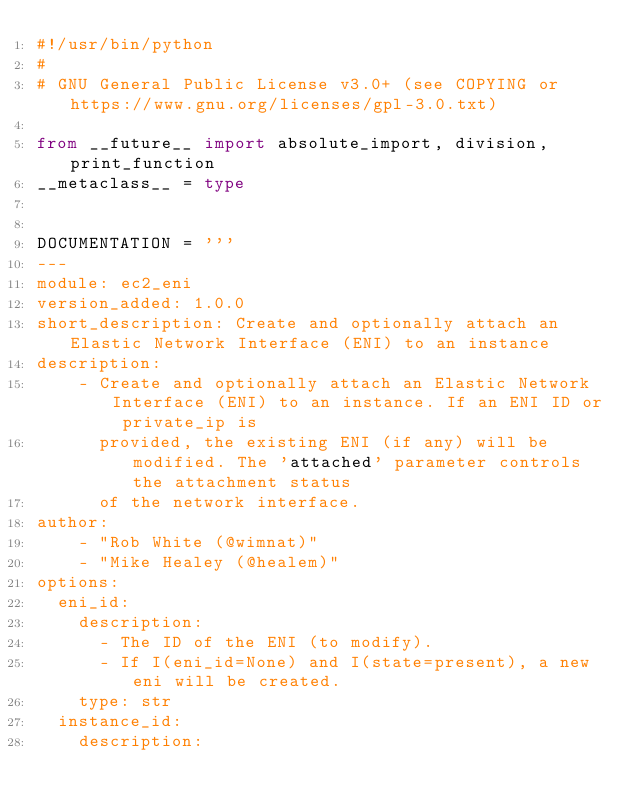<code> <loc_0><loc_0><loc_500><loc_500><_Python_>#!/usr/bin/python
#
# GNU General Public License v3.0+ (see COPYING or https://www.gnu.org/licenses/gpl-3.0.txt)

from __future__ import absolute_import, division, print_function
__metaclass__ = type


DOCUMENTATION = '''
---
module: ec2_eni
version_added: 1.0.0
short_description: Create and optionally attach an Elastic Network Interface (ENI) to an instance
description:
    - Create and optionally attach an Elastic Network Interface (ENI) to an instance. If an ENI ID or private_ip is
      provided, the existing ENI (if any) will be modified. The 'attached' parameter controls the attachment status
      of the network interface.
author:
    - "Rob White (@wimnat)"
    - "Mike Healey (@healem)"
options:
  eni_id:
    description:
      - The ID of the ENI (to modify).
      - If I(eni_id=None) and I(state=present), a new eni will be created.
    type: str
  instance_id:
    description:</code> 